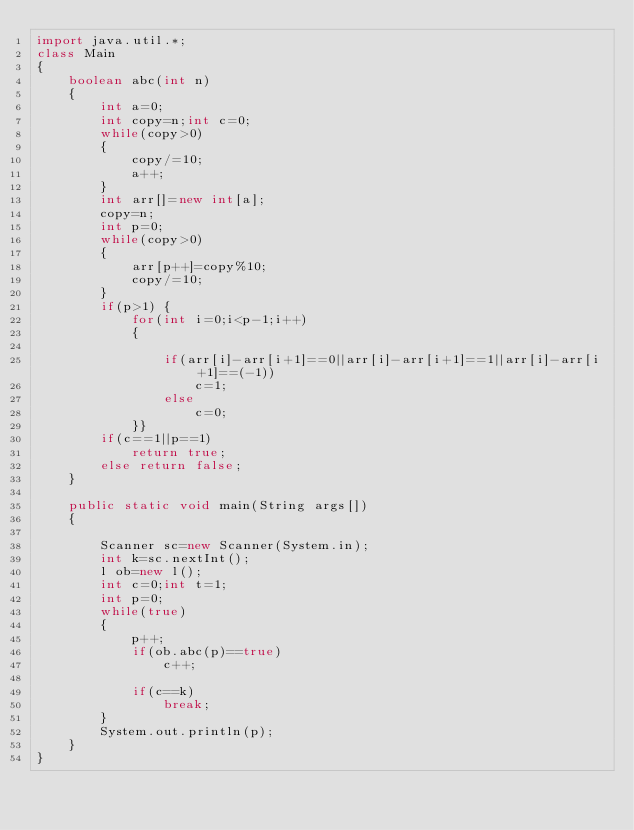<code> <loc_0><loc_0><loc_500><loc_500><_Java_>import java.util.*;
class Main
{
    boolean abc(int n)
    {
        int a=0;
        int copy=n;int c=0;
        while(copy>0)
        {
            copy/=10;
            a++;
        }
        int arr[]=new int[a];
        copy=n;
        int p=0;
        while(copy>0)
        {
            arr[p++]=copy%10;
            copy/=10;
        }
        if(p>1) {
            for(int i=0;i<p-1;i++)
            {

                if(arr[i]-arr[i+1]==0||arr[i]-arr[i+1]==1||arr[i]-arr[i+1]==(-1))
                    c=1;
                else
                    c=0;
            }}
        if(c==1||p==1)
            return true;
        else return false;
    }

    public static void main(String args[])
    {

        Scanner sc=new Scanner(System.in);
        int k=sc.nextInt();
        l ob=new l();
        int c=0;int t=1;
        int p=0;
        while(true)
        {
            p++;
            if(ob.abc(p)==true)
                c++;

            if(c==k)
                break;
        }
        System.out.println(p);
    }
}

        </code> 